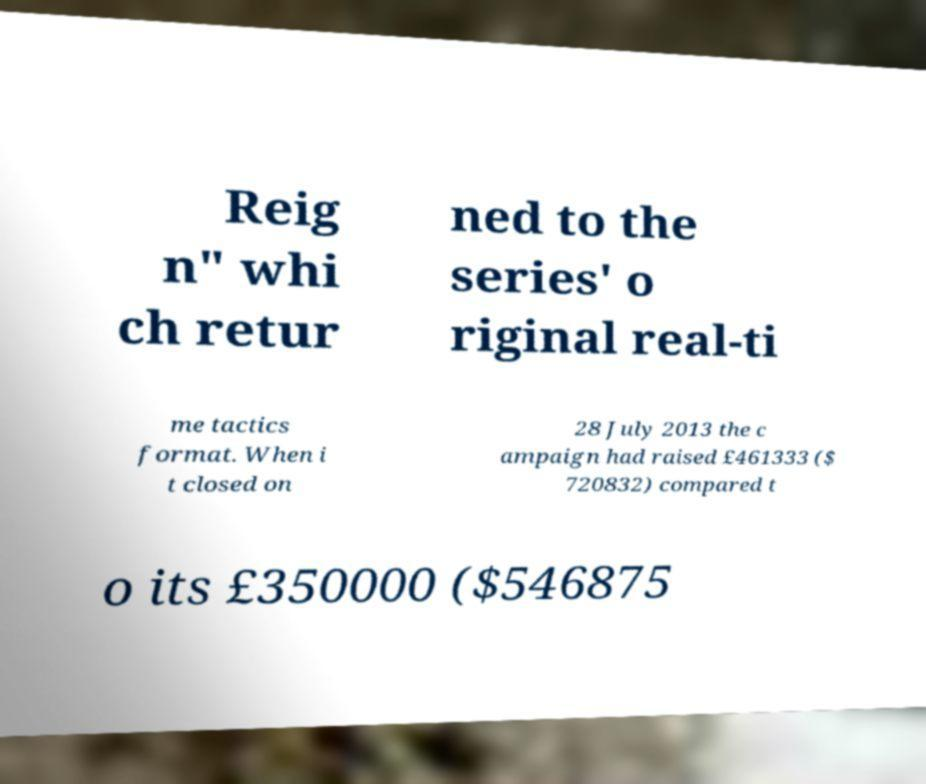I need the written content from this picture converted into text. Can you do that? Reig n" whi ch retur ned to the series' o riginal real-ti me tactics format. When i t closed on 28 July 2013 the c ampaign had raised £461333 ($ 720832) compared t o its £350000 ($546875 